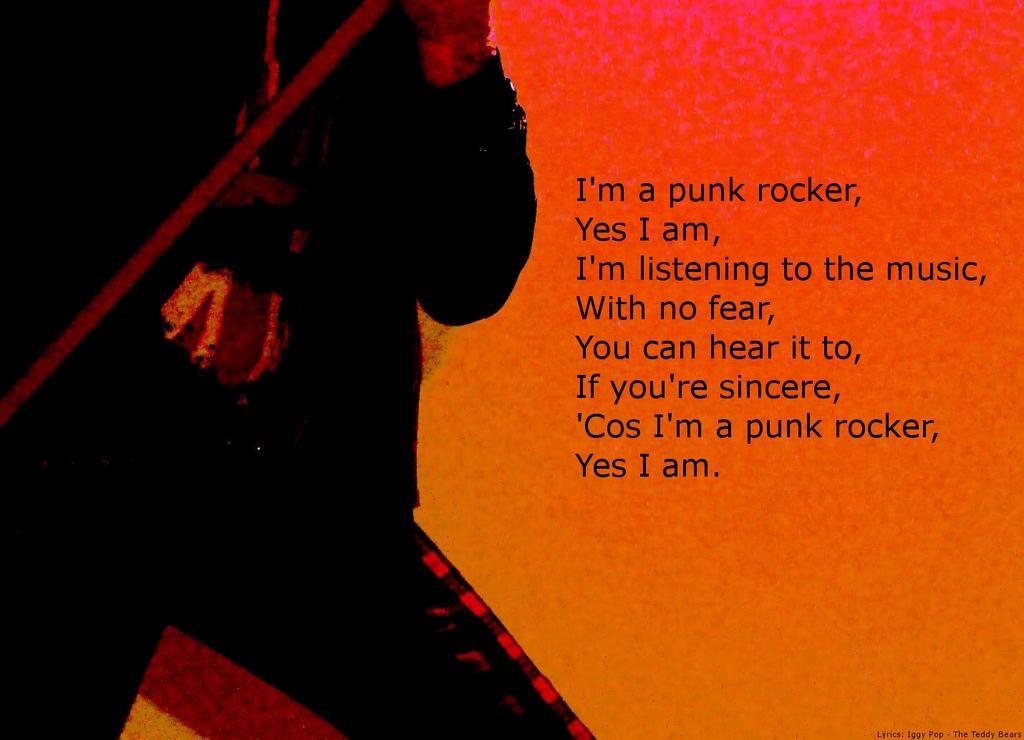In one or two sentences, can you explain what this image depicts? In this image, we can see depiction of a person and some text. 